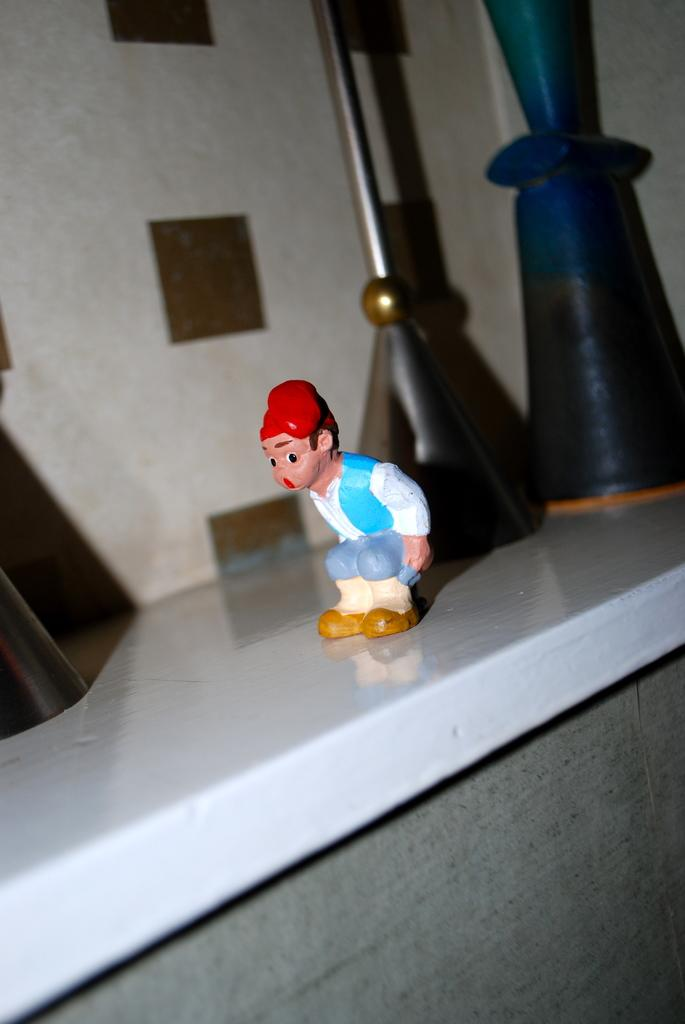What can be seen in the image that is meant for play or entertainment? There is a toy in the image. Where are the objects in the image located? The objects are on a white shelf in the image. What can be seen in the background of the image? There is a wall in the background of the image. What color is the bottom part of the image? The bottom of the image appears to be ash-colored. What type of goat can be seen grazing on the shelf in the image? There is no goat present in the image; it features a toy and objects on a white shelf. What pleasure does the toy provide to the viewer in the image? The image does not convey any information about the viewer's pleasure or emotional response to the toy. 